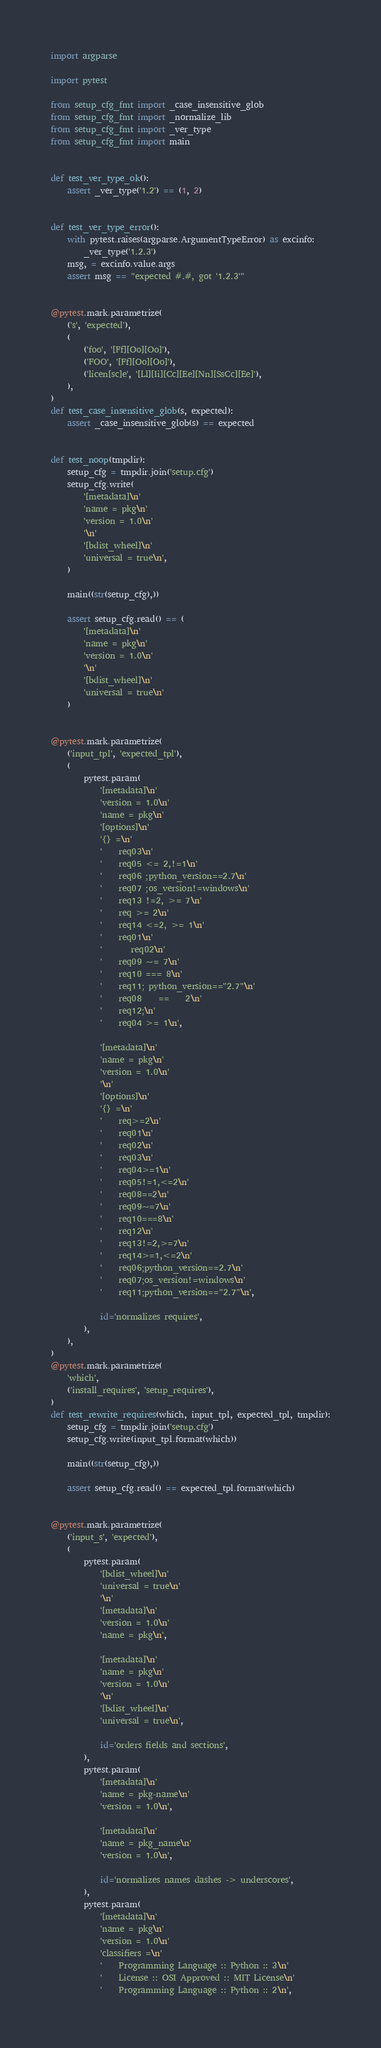Convert code to text. <code><loc_0><loc_0><loc_500><loc_500><_Python_>import argparse

import pytest

from setup_cfg_fmt import _case_insensitive_glob
from setup_cfg_fmt import _normalize_lib
from setup_cfg_fmt import _ver_type
from setup_cfg_fmt import main


def test_ver_type_ok():
    assert _ver_type('1.2') == (1, 2)


def test_ver_type_error():
    with pytest.raises(argparse.ArgumentTypeError) as excinfo:
        _ver_type('1.2.3')
    msg, = excinfo.value.args
    assert msg == "expected #.#, got '1.2.3'"


@pytest.mark.parametrize(
    ('s', 'expected'),
    (
        ('foo', '[Ff][Oo][Oo]'),
        ('FOO', '[Ff][Oo][Oo]'),
        ('licen[sc]e', '[Ll][Ii][Cc][Ee][Nn][SsCc][Ee]'),
    ),
)
def test_case_insensitive_glob(s, expected):
    assert _case_insensitive_glob(s) == expected


def test_noop(tmpdir):
    setup_cfg = tmpdir.join('setup.cfg')
    setup_cfg.write(
        '[metadata]\n'
        'name = pkg\n'
        'version = 1.0\n'
        '\n'
        '[bdist_wheel]\n'
        'universal = true\n',
    )

    main((str(setup_cfg),))

    assert setup_cfg.read() == (
        '[metadata]\n'
        'name = pkg\n'
        'version = 1.0\n'
        '\n'
        '[bdist_wheel]\n'
        'universal = true\n'
    )


@pytest.mark.parametrize(
    ('input_tpl', 'expected_tpl'),
    (
        pytest.param(
            '[metadata]\n'
            'version = 1.0\n'
            'name = pkg\n'
            '[options]\n'
            '{} =\n'
            '    req03\n'
            '    req05 <= 2,!=1\n'
            '    req06 ;python_version==2.7\n'
            '    req07 ;os_version!=windows\n'
            '    req13 !=2, >= 7\n'
            '    req >= 2\n'
            '    req14 <=2, >= 1\n'
            '    req01\n'
            '       req02\n'
            '    req09 ~= 7\n'
            '    req10 === 8\n'
            '    req11; python_version=="2.7"\n'
            '    req08    ==    2\n'
            '    req12;\n'
            '    req04 >= 1\n',

            '[metadata]\n'
            'name = pkg\n'
            'version = 1.0\n'
            '\n'
            '[options]\n'
            '{} =\n'
            '    req>=2\n'
            '    req01\n'
            '    req02\n'
            '    req03\n'
            '    req04>=1\n'
            '    req05!=1,<=2\n'
            '    req08==2\n'
            '    req09~=7\n'
            '    req10===8\n'
            '    req12\n'
            '    req13!=2,>=7\n'
            '    req14>=1,<=2\n'
            '    req06;python_version==2.7\n'
            '    req07;os_version!=windows\n'
            '    req11;python_version=="2.7"\n',

            id='normalizes requires',
        ),
    ),
)
@pytest.mark.parametrize(
    'which',
    ('install_requires', 'setup_requires'),
)
def test_rewrite_requires(which, input_tpl, expected_tpl, tmpdir):
    setup_cfg = tmpdir.join('setup.cfg')
    setup_cfg.write(input_tpl.format(which))

    main((str(setup_cfg),))

    assert setup_cfg.read() == expected_tpl.format(which)


@pytest.mark.parametrize(
    ('input_s', 'expected'),
    (
        pytest.param(
            '[bdist_wheel]\n'
            'universal = true\n'
            '\n'
            '[metadata]\n'
            'version = 1.0\n'
            'name = pkg\n',

            '[metadata]\n'
            'name = pkg\n'
            'version = 1.0\n'
            '\n'
            '[bdist_wheel]\n'
            'universal = true\n',

            id='orders fields and sections',
        ),
        pytest.param(
            '[metadata]\n'
            'name = pkg-name\n'
            'version = 1.0\n',

            '[metadata]\n'
            'name = pkg_name\n'
            'version = 1.0\n',

            id='normalizes names dashes -> underscores',
        ),
        pytest.param(
            '[metadata]\n'
            'name = pkg\n'
            'version = 1.0\n'
            'classifiers =\n'
            '    Programming Language :: Python :: 3\n'
            '    License :: OSI Approved :: MIT License\n'
            '    Programming Language :: Python :: 2\n',
</code> 